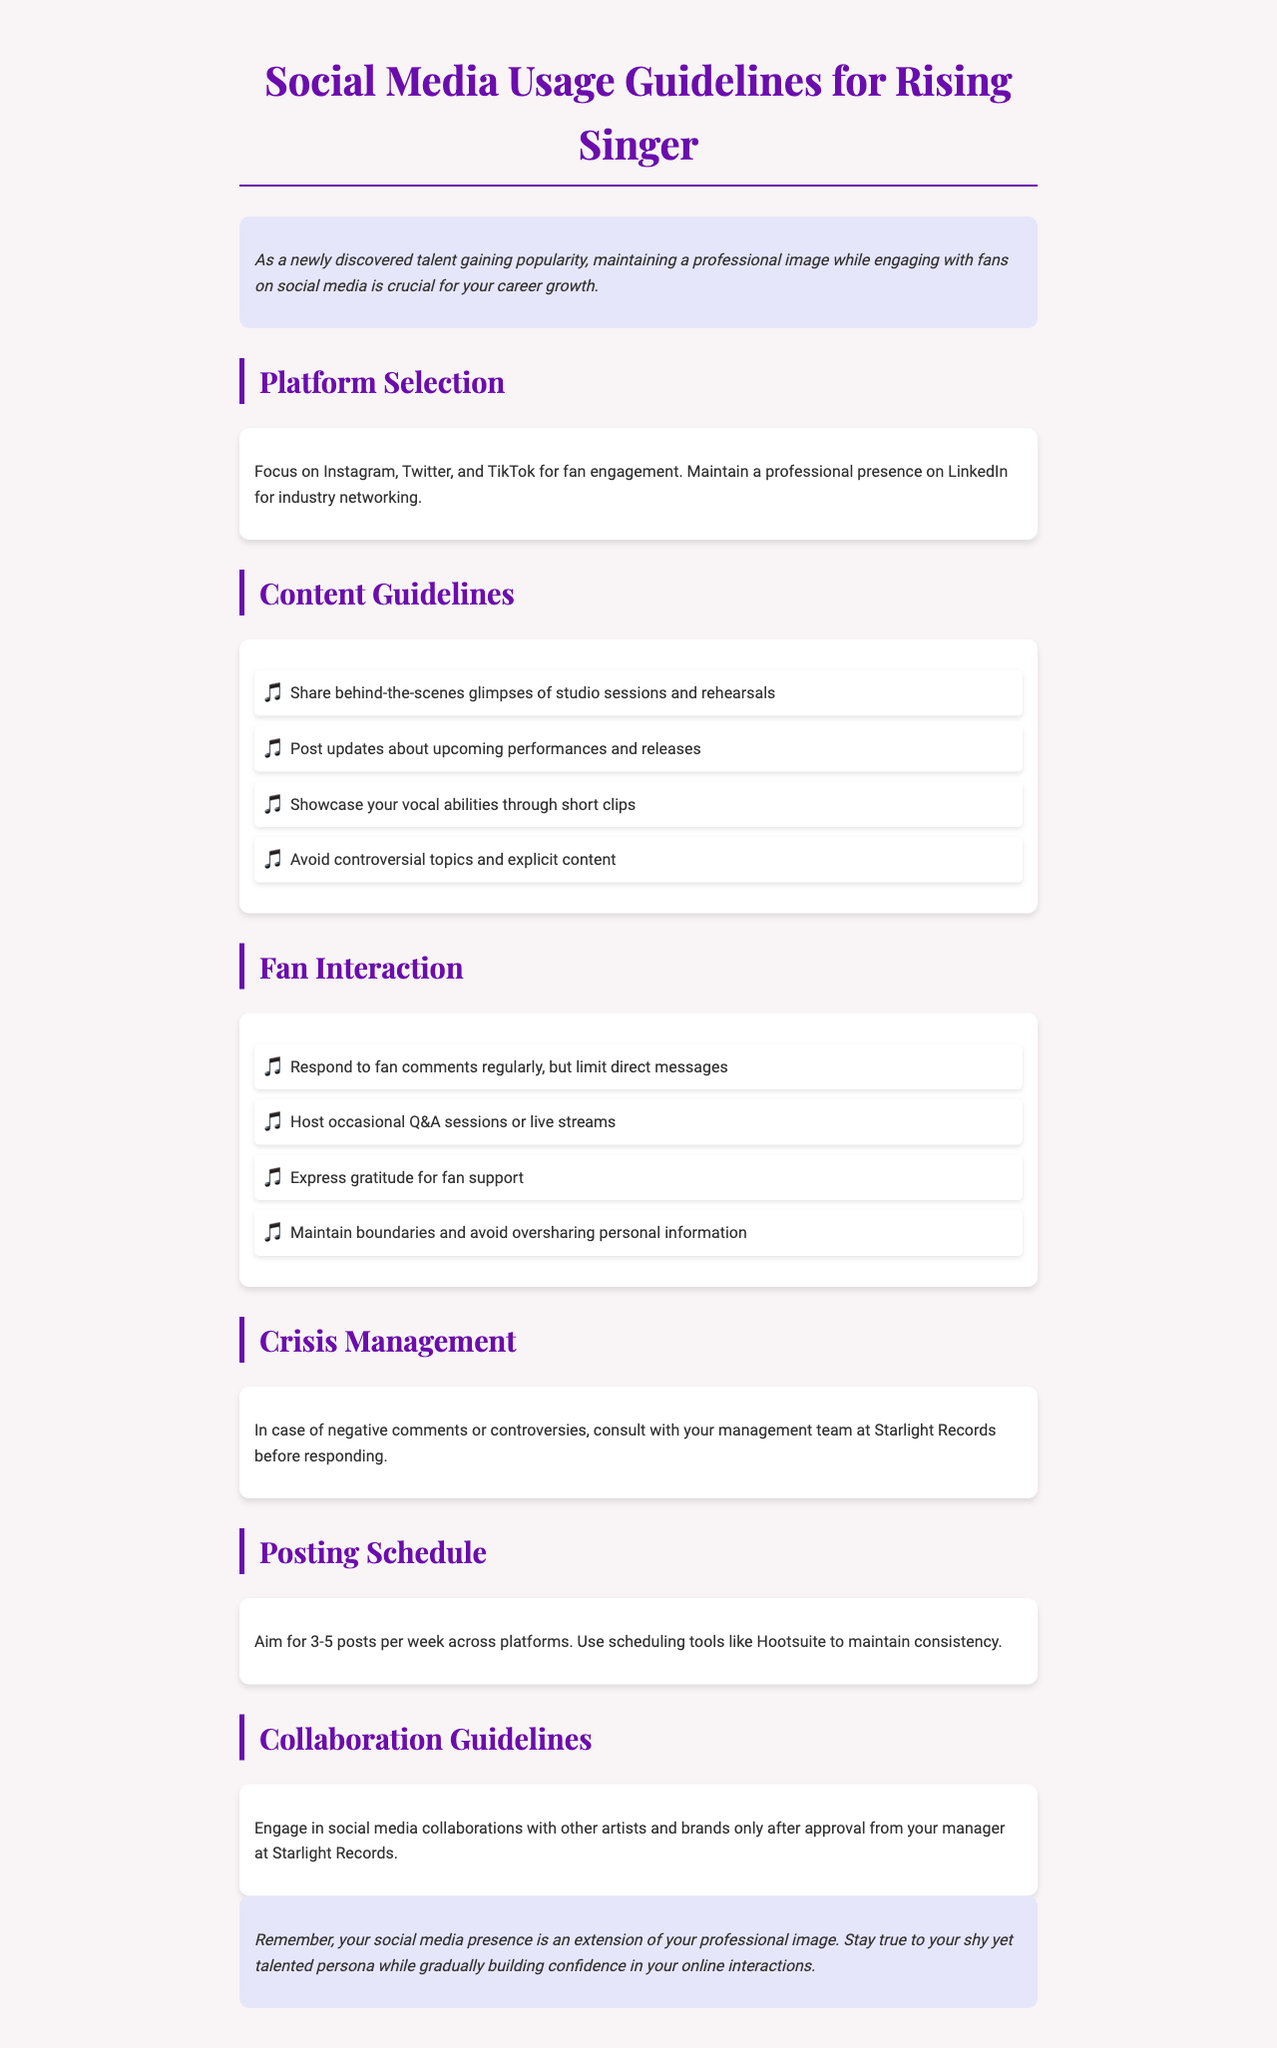What are the recommended social media platforms? The document lists Instagram, Twitter, and TikTok for fan engagement and LinkedIn for industry networking as the recommended social media platforms.
Answer: Instagram, Twitter, TikTok, LinkedIn How many posts should you aim for per week? The document suggests aiming for 3-5 posts per week across platforms.
Answer: 3-5 posts What should you avoid posting about? The guidelines specify avoiding controversial topics and explicit content.
Answer: Controversial topics and explicit content Who should you consult with before responding to negative comments? The document states to consult with your management team at Starlight Records before responding to negative comments or controversies.
Answer: Management team at Starlight Records What is the main purpose of these guidelines? The guidelines emphasize that maintaining a professional image while engaging with fans on social media is crucial for career growth.
Answer: Maintain a professional image How often should you respond to fan comments? The document advises to respond to fan comments regularly but limit direct messages.
Answer: Regularly, limit direct messages What type of sessions can you host occasionally? The guidelines suggest hosting occasional Q&A sessions or live streams.
Answer: Q&A sessions or live streams What is suggested for scheduling posts? The document recommends using scheduling tools like Hootsuite to maintain consistency in posting.
Answer: Hootsuite 